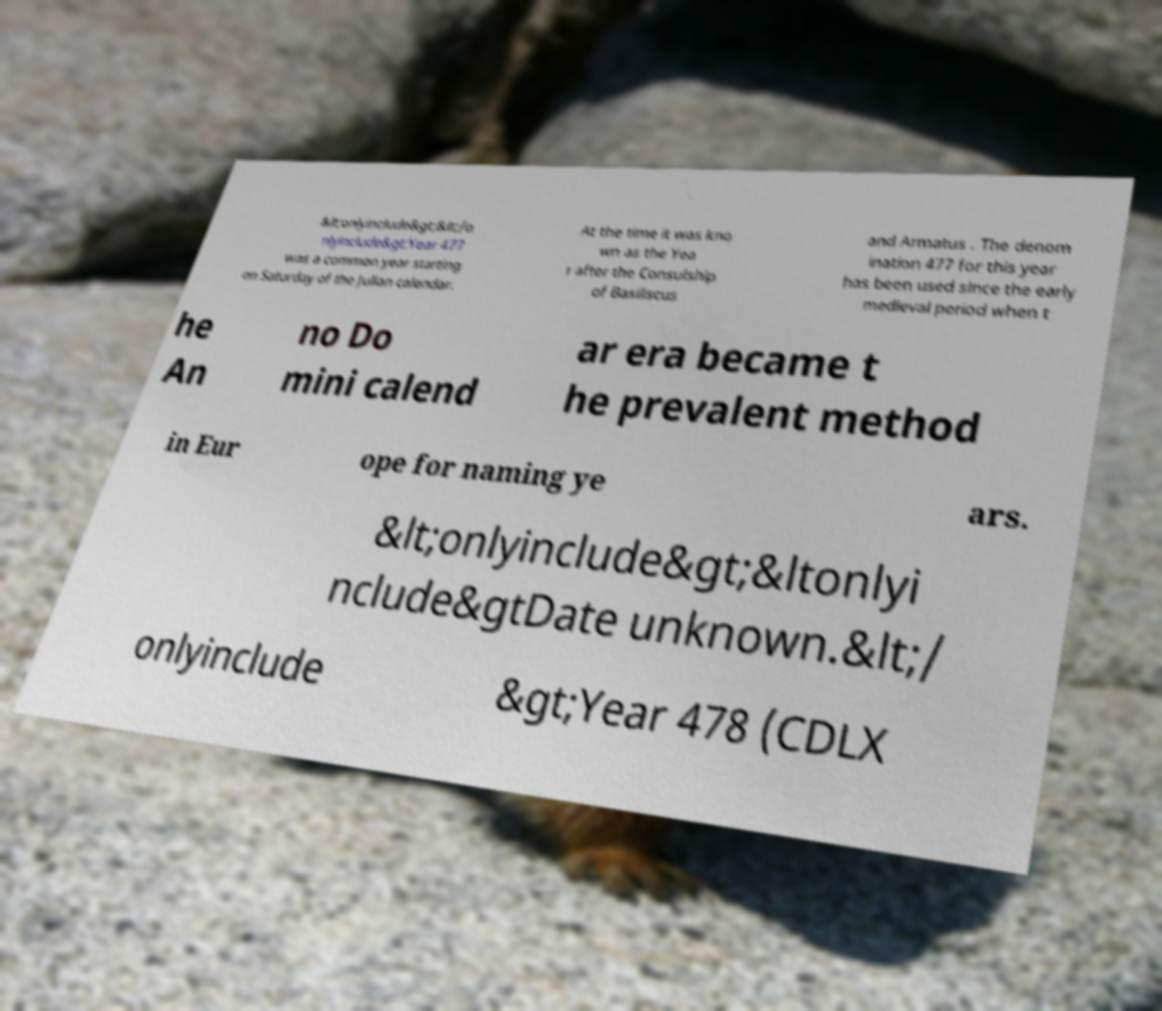I need the written content from this picture converted into text. Can you do that? &lt;onlyinclude&gt;&lt;/o nlyinclude&gt;Year 477 was a common year starting on Saturday of the Julian calendar. At the time it was kno wn as the Yea r after the Consulship of Basiliscus and Armatus . The denom ination 477 for this year has been used since the early medieval period when t he An no Do mini calend ar era became t he prevalent method in Eur ope for naming ye ars. &lt;onlyinclude&gt;&ltonlyi nclude&gtDate unknown.&lt;/ onlyinclude &gt;Year 478 (CDLX 